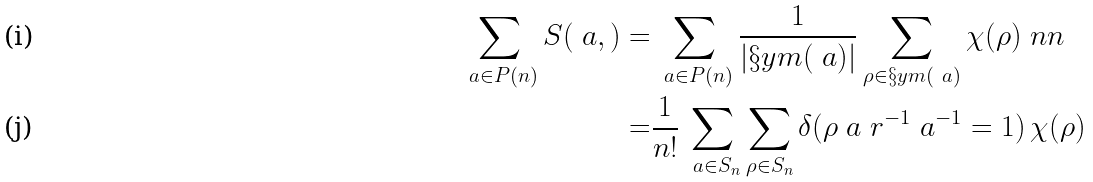<formula> <loc_0><loc_0><loc_500><loc_500>\sum _ { \ a \in P ( n ) } S ( \ a , \L ) = & \sum _ { \ a \in P ( n ) } \frac { 1 } { | \S y m ( \ a ) | } \sum _ { \rho \in \S y m ( \ a ) } \chi _ { \L } ( \rho ) \ n n \\ = & \frac { 1 } { n ! } \sum _ { \ a \in S _ { n } } \sum _ { \rho \in S _ { n } } \delta ( \rho \ a \ r ^ { - 1 } \ a ^ { - 1 } = 1 ) \, \chi _ { \L } ( \rho )</formula> 